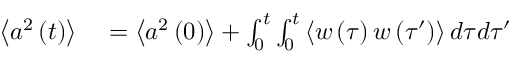Convert formula to latex. <formula><loc_0><loc_0><loc_500><loc_500>\begin{array} { r l } { \left \langle a ^ { 2 } \left ( t \right ) \right \rangle } & = \left \langle a ^ { 2 } \left ( 0 \right ) \right \rangle + \int _ { 0 } ^ { t } \int _ { 0 } ^ { t } \left \langle w \left ( \tau \right ) w \left ( \tau ^ { \prime } \right ) \right \rangle d \tau d \tau ^ { \prime } } \end{array}</formula> 